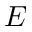Convert formula to latex. <formula><loc_0><loc_0><loc_500><loc_500>E</formula> 